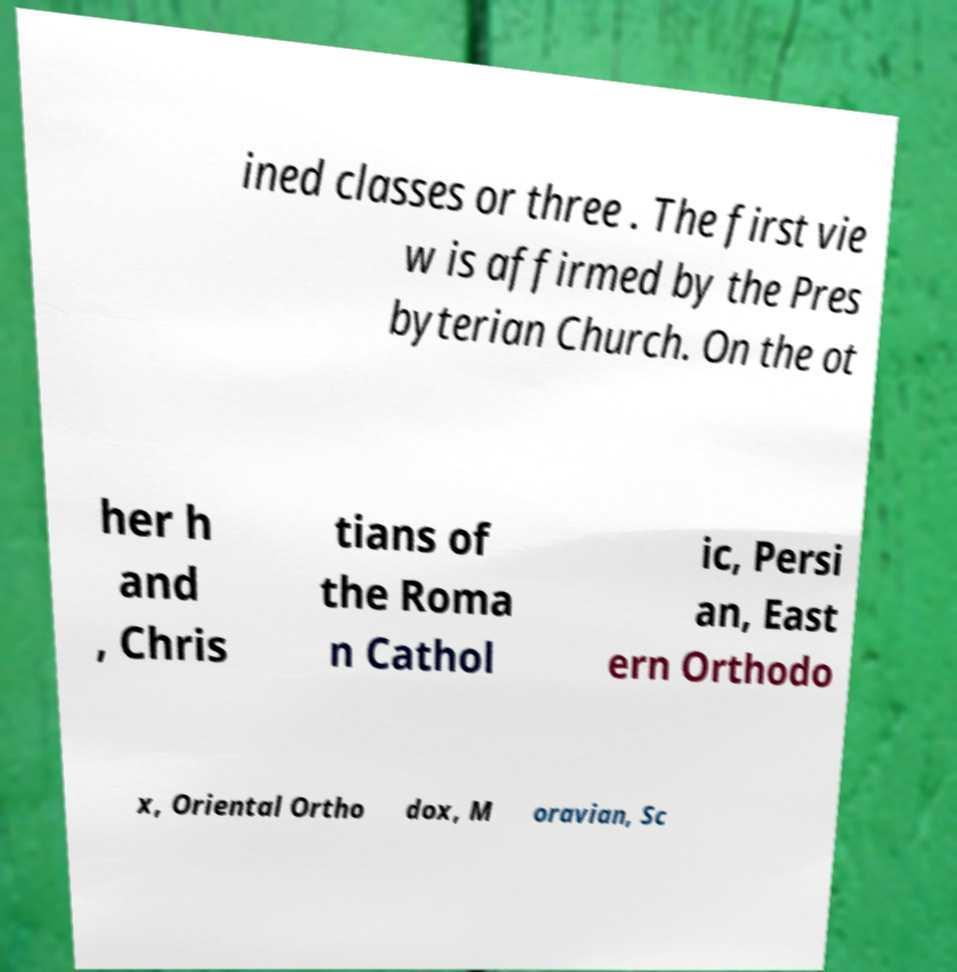Can you read and provide the text displayed in the image?This photo seems to have some interesting text. Can you extract and type it out for me? ined classes or three . The first vie w is affirmed by the Pres byterian Church. On the ot her h and , Chris tians of the Roma n Cathol ic, Persi an, East ern Orthodo x, Oriental Ortho dox, M oravian, Sc 